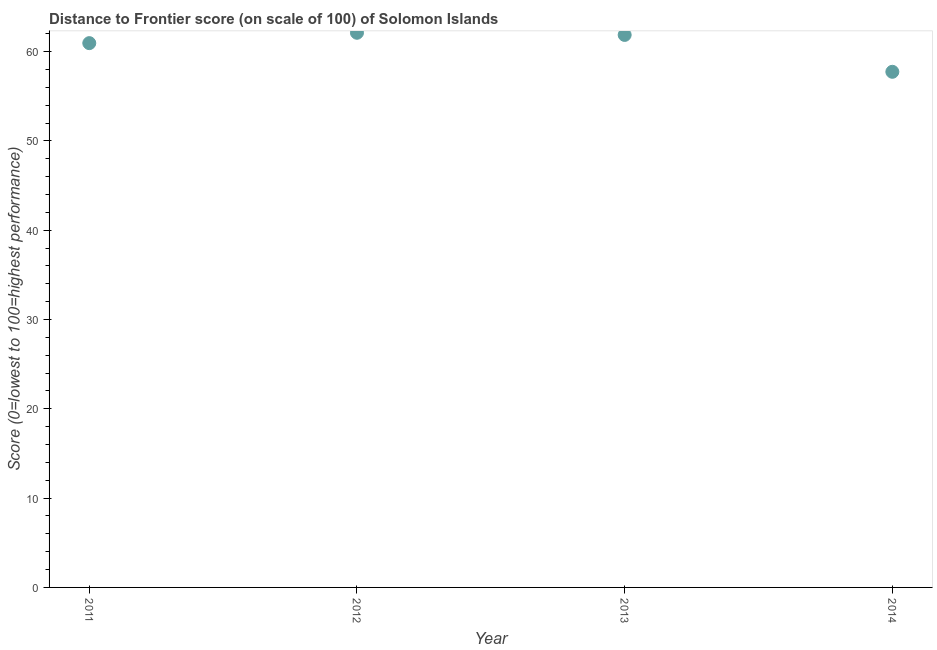What is the distance to frontier score in 2011?
Your answer should be compact. 60.95. Across all years, what is the maximum distance to frontier score?
Your answer should be very brief. 62.11. Across all years, what is the minimum distance to frontier score?
Your answer should be compact. 57.74. In which year was the distance to frontier score maximum?
Offer a terse response. 2012. What is the sum of the distance to frontier score?
Provide a short and direct response. 242.67. What is the difference between the distance to frontier score in 2013 and 2014?
Keep it short and to the point. 4.13. What is the average distance to frontier score per year?
Provide a succinct answer. 60.67. What is the median distance to frontier score?
Offer a very short reply. 61.41. What is the ratio of the distance to frontier score in 2011 to that in 2014?
Ensure brevity in your answer.  1.06. Is the difference between the distance to frontier score in 2012 and 2014 greater than the difference between any two years?
Your response must be concise. Yes. What is the difference between the highest and the second highest distance to frontier score?
Keep it short and to the point. 0.24. Is the sum of the distance to frontier score in 2013 and 2014 greater than the maximum distance to frontier score across all years?
Ensure brevity in your answer.  Yes. What is the difference between the highest and the lowest distance to frontier score?
Your answer should be compact. 4.37. In how many years, is the distance to frontier score greater than the average distance to frontier score taken over all years?
Provide a short and direct response. 3. How many dotlines are there?
Offer a very short reply. 1. What is the difference between two consecutive major ticks on the Y-axis?
Keep it short and to the point. 10. Does the graph contain any zero values?
Provide a short and direct response. No. What is the title of the graph?
Provide a short and direct response. Distance to Frontier score (on scale of 100) of Solomon Islands. What is the label or title of the Y-axis?
Your response must be concise. Score (0=lowest to 100=highest performance). What is the Score (0=lowest to 100=highest performance) in 2011?
Offer a very short reply. 60.95. What is the Score (0=lowest to 100=highest performance) in 2012?
Your answer should be compact. 62.11. What is the Score (0=lowest to 100=highest performance) in 2013?
Give a very brief answer. 61.87. What is the Score (0=lowest to 100=highest performance) in 2014?
Your answer should be compact. 57.74. What is the difference between the Score (0=lowest to 100=highest performance) in 2011 and 2012?
Your response must be concise. -1.16. What is the difference between the Score (0=lowest to 100=highest performance) in 2011 and 2013?
Offer a very short reply. -0.92. What is the difference between the Score (0=lowest to 100=highest performance) in 2011 and 2014?
Give a very brief answer. 3.21. What is the difference between the Score (0=lowest to 100=highest performance) in 2012 and 2013?
Provide a succinct answer. 0.24. What is the difference between the Score (0=lowest to 100=highest performance) in 2012 and 2014?
Offer a very short reply. 4.37. What is the difference between the Score (0=lowest to 100=highest performance) in 2013 and 2014?
Ensure brevity in your answer.  4.13. What is the ratio of the Score (0=lowest to 100=highest performance) in 2011 to that in 2012?
Offer a terse response. 0.98. What is the ratio of the Score (0=lowest to 100=highest performance) in 2011 to that in 2014?
Keep it short and to the point. 1.06. What is the ratio of the Score (0=lowest to 100=highest performance) in 2012 to that in 2013?
Make the answer very short. 1. What is the ratio of the Score (0=lowest to 100=highest performance) in 2012 to that in 2014?
Make the answer very short. 1.08. What is the ratio of the Score (0=lowest to 100=highest performance) in 2013 to that in 2014?
Provide a succinct answer. 1.07. 